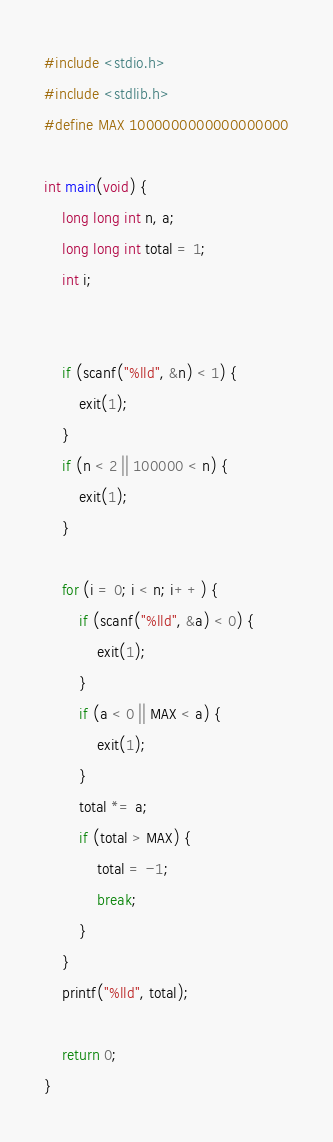<code> <loc_0><loc_0><loc_500><loc_500><_C_>#include <stdio.h>
#include <stdlib.h>
#define MAX 1000000000000000000

int main(void) {
	long long int n, a;
	long long int total = 1;
	int i;


	if (scanf("%lld", &n) < 1) {
		exit(1);
	}
	if (n < 2 || 100000 < n) {
		exit(1);
	}

	for (i = 0; i < n; i++) {
		if (scanf("%lld", &a) < 0) {
			exit(1);
		}
		if (a < 0 || MAX < a) {
			exit(1);
		}
		total *= a;
		if (total > MAX) {
			total = -1;
			break;
		}
	}
	printf("%lld", total);

	return 0;
}</code> 